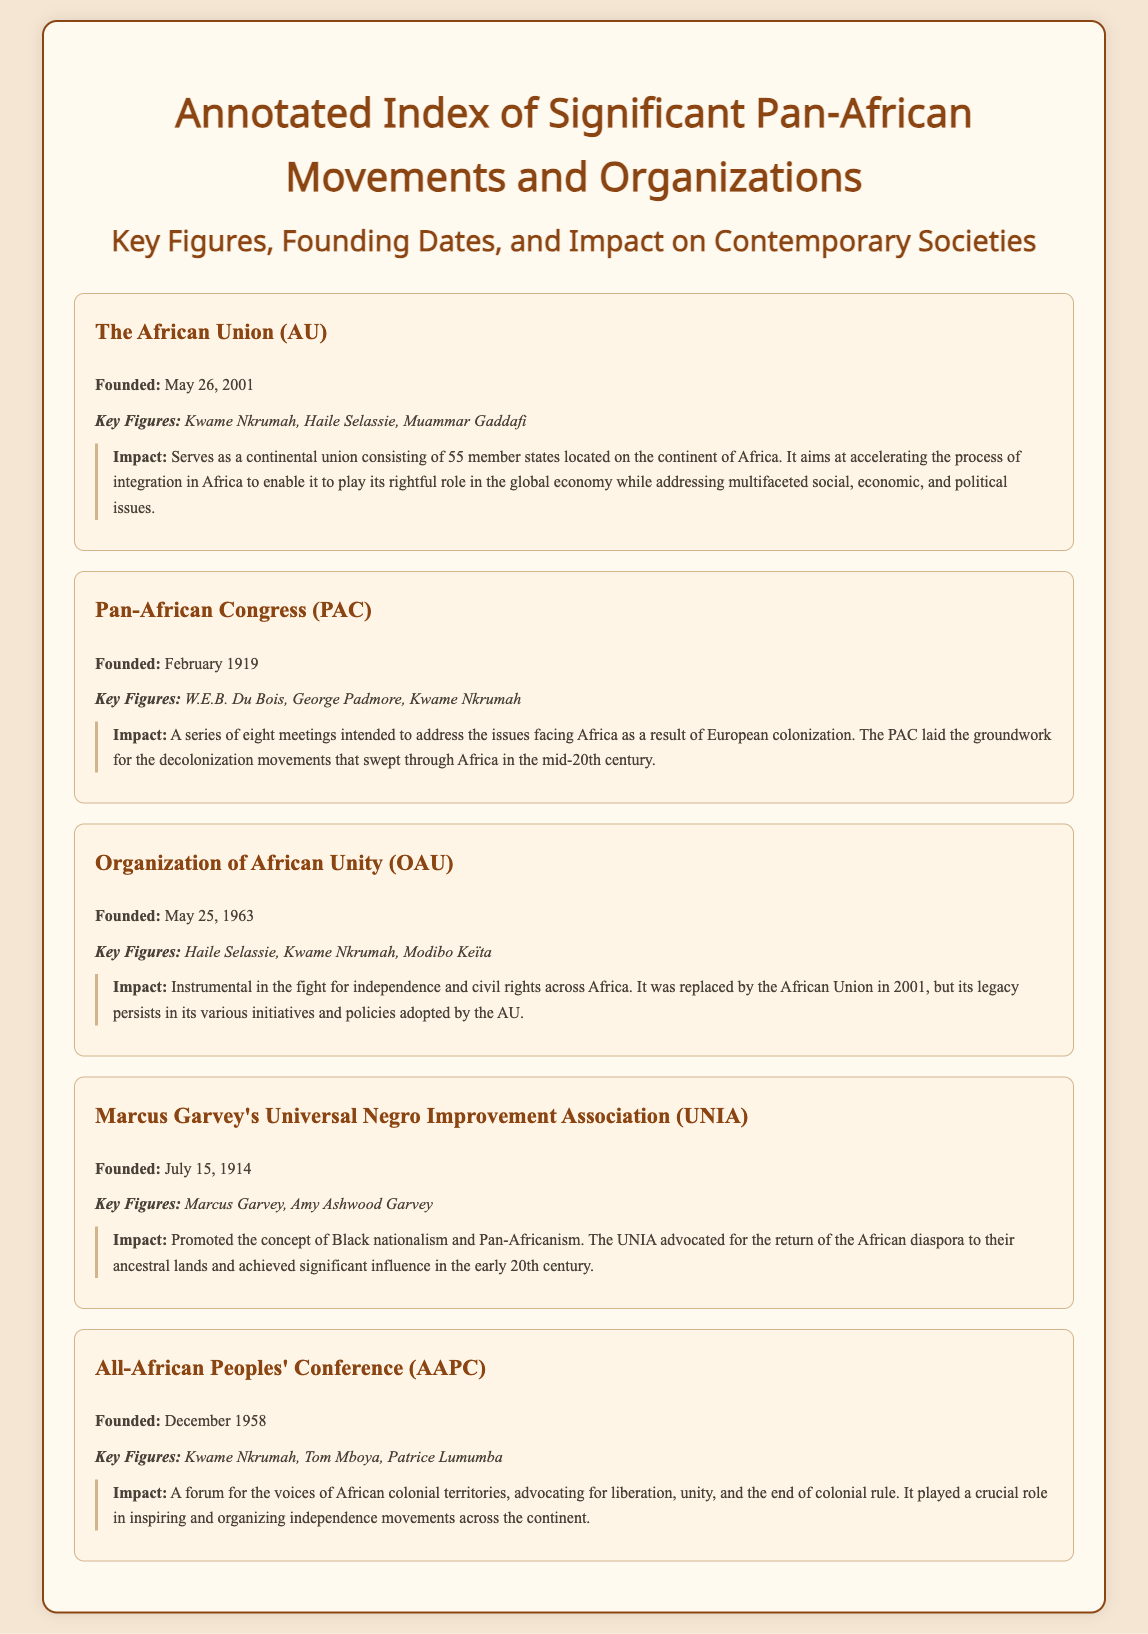What year was the African Union founded? The founding date for the African Union is specifically mentioned in the document as May 26, 2001.
Answer: May 26, 2001 Who was a key figure in the Pan-African Congress? The document lists W.E.B. Du Bois, George Padmore, and Kwame Nkrumah as key figures, highlighting their contributions.
Answer: W.E.B. Du Bois When was the Organization of African Unity founded? The founding date of the Organization of African Unity is documented as May 25, 1963.
Answer: May 25, 1963 What was the main focus of Marcus Garvey's UNIA? The impact section of the UNIA entry describes its promotion of Black nationalism and Pan-Africanism, reflecting its main focus.
Answer: Black nationalism Which organization was established before the African Union? The document specifies the Organization of African Unity was replaced by the African Union in 2001.
Answer: Organization of African Unity What event did the All-African Peoples' Conference serve as a forum for? The document states that the AAPC was a forum advocating for liberation, unity, and the end of colonial rule.
Answer: Colonial rule Who were the founding figures of the UNIA? The document lists Marcus Garvey and Amy Ashwood Garvey as the founding figures of the UNIA.
Answer: Marcus Garvey, Amy Ashwood Garvey 